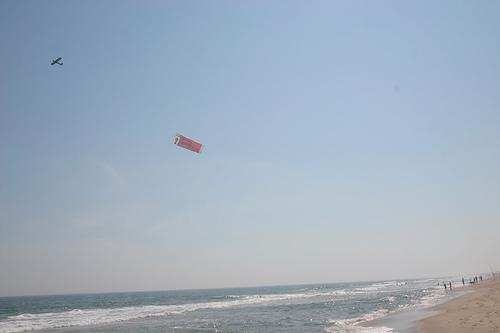Question: where is the kite?
Choices:
A. On ground.
B. In package.
C. Flying.
D. In trash, broken.
Answer with the letter. Answer: C Question: where was the photo taken?
Choices:
A. At the desert.
B. At the beach.
C. At the river.
D. At the lake.
Answer with the letter. Answer: B 